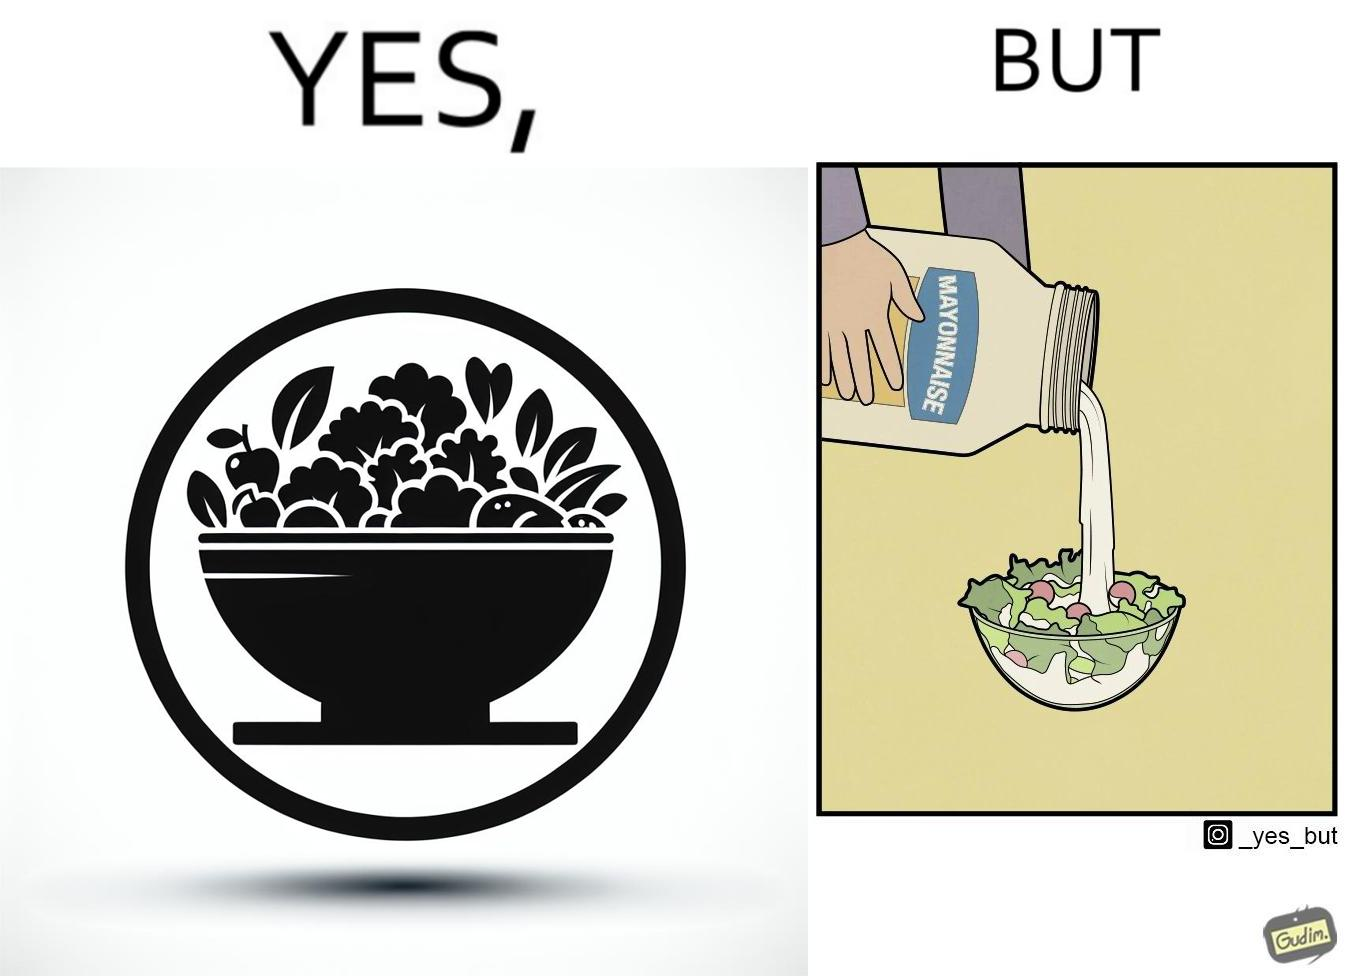Provide a description of this image. The image is ironical, as salad in a bowl by itself is very healthy. However, when people have it with Mayonnaise sauce to improve the taste, it is not healthy anymore, and defeats the point of having nutrient-rich salad altogether. 